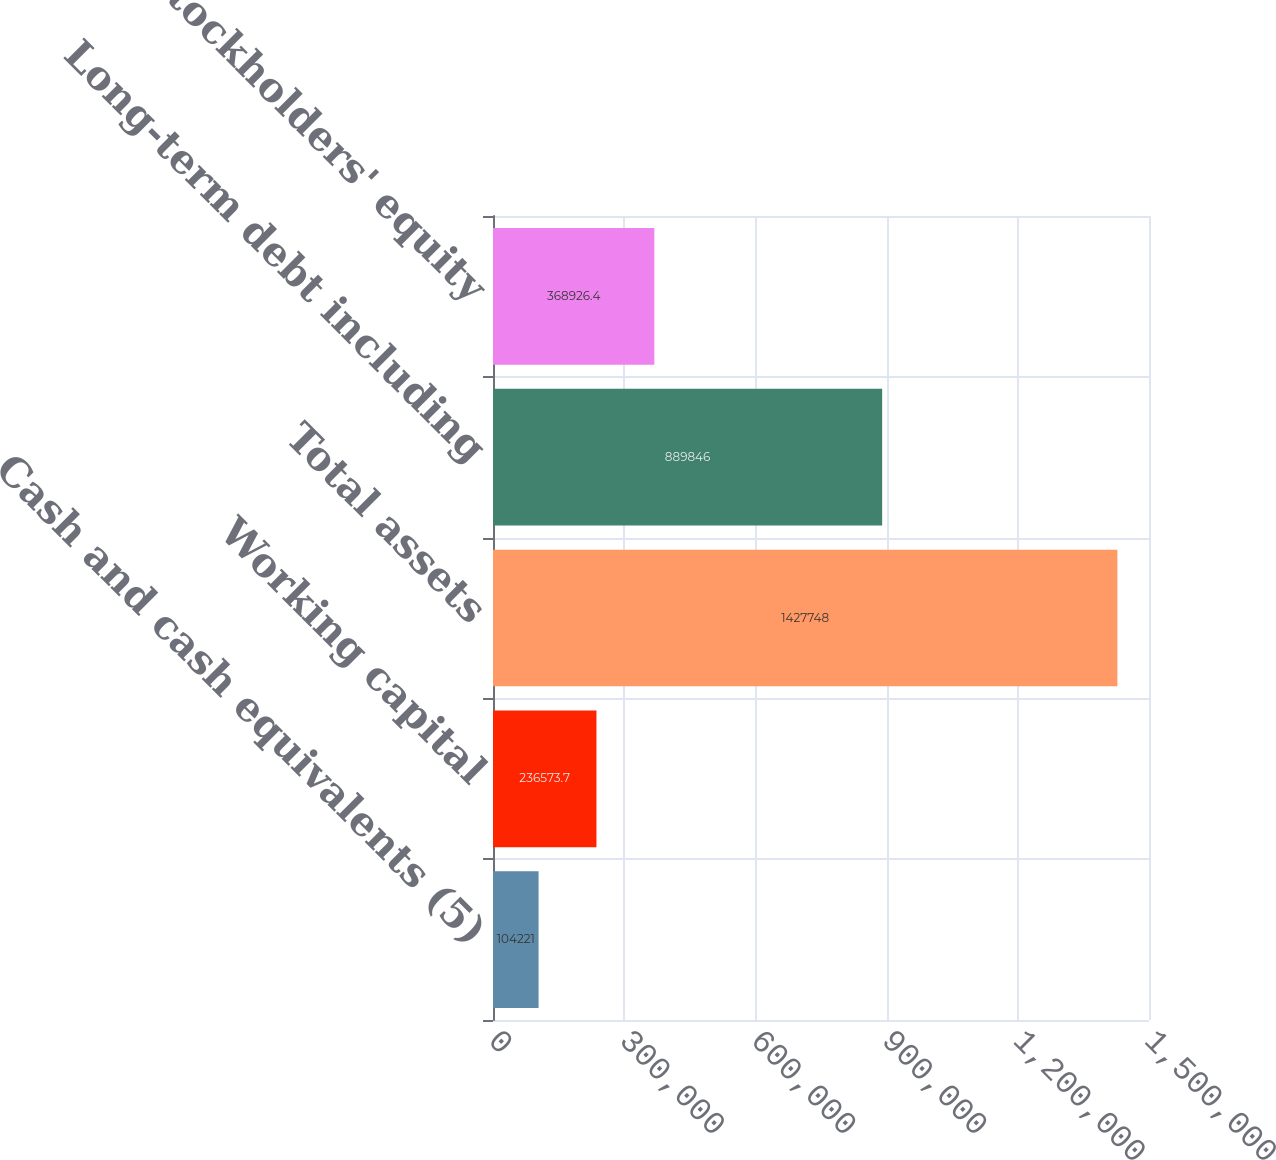Convert chart to OTSL. <chart><loc_0><loc_0><loc_500><loc_500><bar_chart><fcel>Cash and cash equivalents (5)<fcel>Working capital<fcel>Total assets<fcel>Long-term debt including<fcel>Stockholders' equity<nl><fcel>104221<fcel>236574<fcel>1.42775e+06<fcel>889846<fcel>368926<nl></chart> 